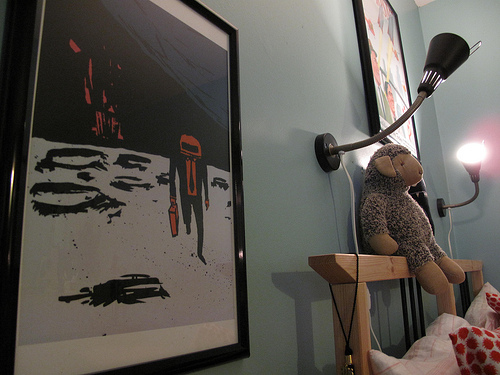<image>
Is the stuffed animal on the pillow? No. The stuffed animal is not positioned on the pillow. They may be near each other, but the stuffed animal is not supported by or resting on top of the pillow. 